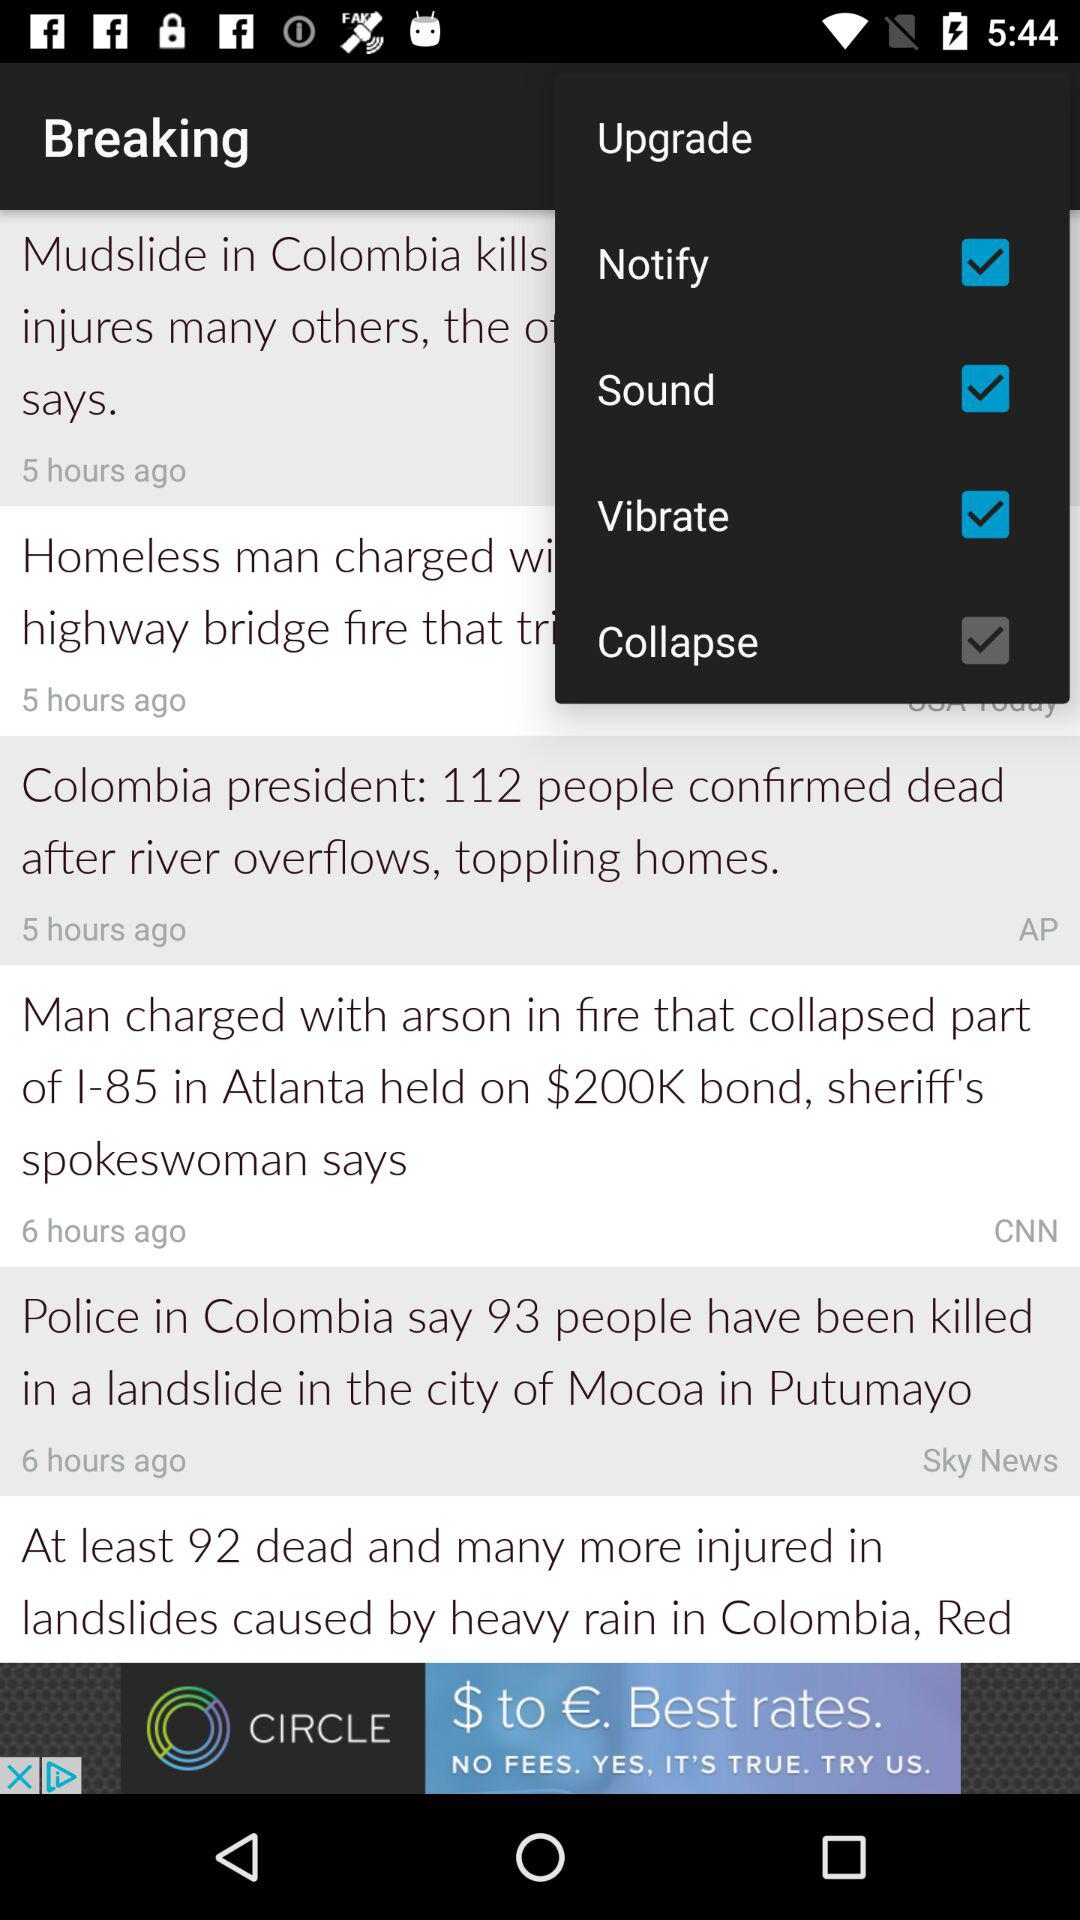What news broke five hours ago? The news that broke five hours ago was "Colombia president: 112 people confirmed dead after river overflows, toppling homes". 